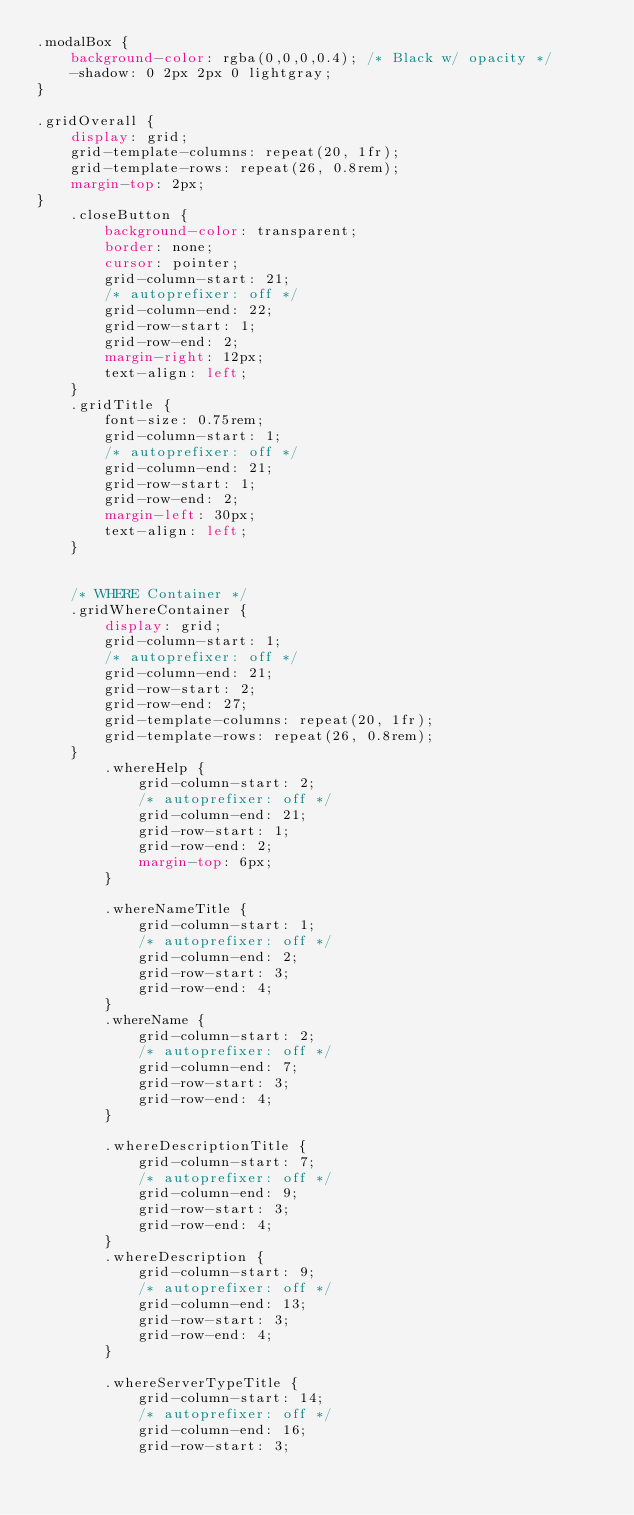<code> <loc_0><loc_0><loc_500><loc_500><_CSS_>.modalBox {
	background-color: rgba(0,0,0,0.4); /* Black w/ opacity */
	-shadow: 0 2px 2px 0 lightgray;
}

.gridOverall {
    display: grid;
    grid-template-columns: repeat(20, 1fr);
    grid-template-rows: repeat(26, 0.8rem);
    margin-top: 2px;
}
    .closeButton {
        background-color: transparent;
        border: none;
        cursor: pointer;
        grid-column-start: 21;
        /* autoprefixer: off */
        grid-column-end: 22;
        grid-row-start: 1;
        grid-row-end: 2;
        margin-right: 12px;
        text-align: left;
    }
    .gridTitle {
        font-size: 0.75rem;
        grid-column-start: 1;
        /* autoprefixer: off */
        grid-column-end: 21;
        grid-row-start: 1;
        grid-row-end: 2;
        margin-left: 30px;
        text-align: left;
    }


    /* WHERE Container */
    .gridWhereContainer {
        display: grid;
        grid-column-start: 1;
        /* autoprefixer: off */
        grid-column-end: 21;
        grid-row-start: 2;
        grid-row-end: 27;
        grid-template-columns: repeat(20, 1fr);
        grid-template-rows: repeat(26, 0.8rem);
    }
        .whereHelp {
            grid-column-start: 2;
            /* autoprefixer: off */
            grid-column-end: 21;
            grid-row-start: 1;
            grid-row-end: 2;
            margin-top: 6px;
        }

        .whereNameTitle {
            grid-column-start: 1;
            /* autoprefixer: off */
            grid-column-end: 2;
            grid-row-start: 3;
            grid-row-end: 4;
        }
        .whereName {
            grid-column-start: 2;
            /* autoprefixer: off */
            grid-column-end: 7;
            grid-row-start: 3;
            grid-row-end: 4;
        }

        .whereDescriptionTitle {
            grid-column-start: 7;
            /* autoprefixer: off */
            grid-column-end: 9;
            grid-row-start: 3;
            grid-row-end: 4;
        }
        .whereDescription {
            grid-column-start: 9;
            /* autoprefixer: off */
            grid-column-end: 13;
            grid-row-start: 3;
            grid-row-end: 4;
        }

        .whereServerTypeTitle {
            grid-column-start: 14;
            /* autoprefixer: off */
            grid-column-end: 16;
            grid-row-start: 3;</code> 